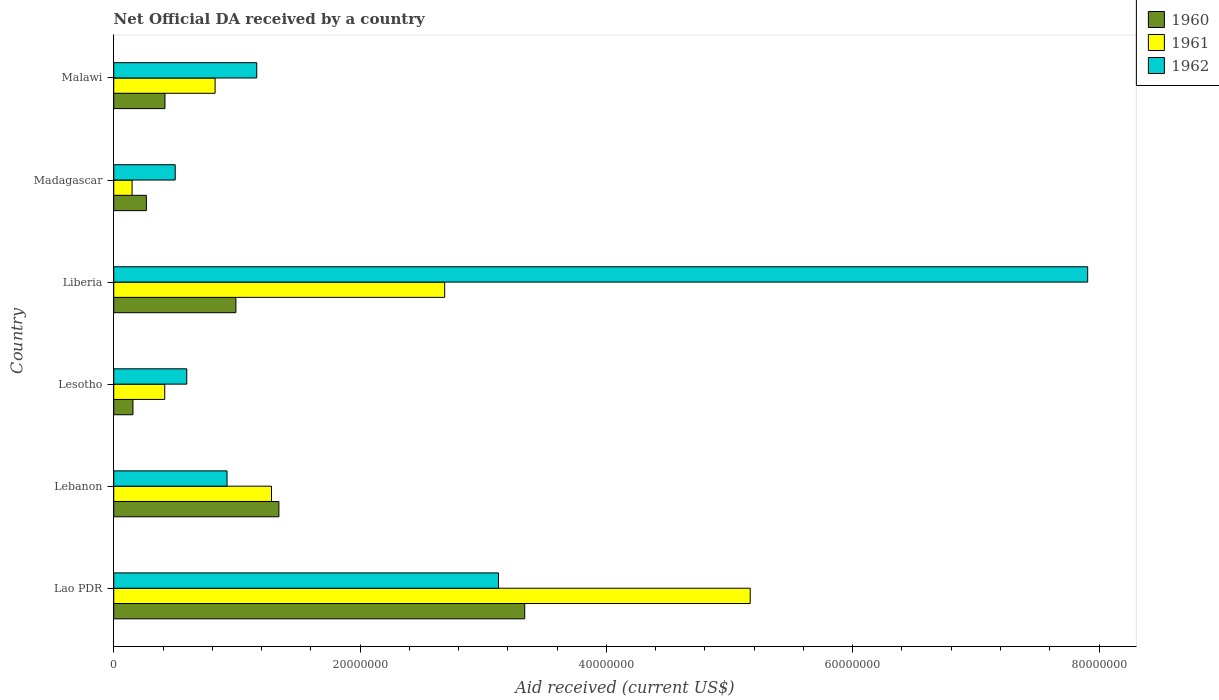How many different coloured bars are there?
Keep it short and to the point. 3. Are the number of bars on each tick of the Y-axis equal?
Your response must be concise. Yes. How many bars are there on the 1st tick from the top?
Ensure brevity in your answer.  3. How many bars are there on the 5th tick from the bottom?
Offer a very short reply. 3. What is the label of the 2nd group of bars from the top?
Make the answer very short. Madagascar. What is the net official development assistance aid received in 1962 in Liberia?
Your response must be concise. 7.91e+07. Across all countries, what is the maximum net official development assistance aid received in 1960?
Keep it short and to the point. 3.34e+07. Across all countries, what is the minimum net official development assistance aid received in 1960?
Give a very brief answer. 1.56e+06. In which country was the net official development assistance aid received in 1961 maximum?
Provide a succinct answer. Lao PDR. In which country was the net official development assistance aid received in 1961 minimum?
Your answer should be very brief. Madagascar. What is the total net official development assistance aid received in 1961 in the graph?
Your answer should be very brief. 1.05e+08. What is the difference between the net official development assistance aid received in 1961 in Lebanon and that in Liberia?
Your answer should be very brief. -1.41e+07. What is the difference between the net official development assistance aid received in 1961 in Liberia and the net official development assistance aid received in 1960 in Lebanon?
Your answer should be compact. 1.35e+07. What is the average net official development assistance aid received in 1961 per country?
Make the answer very short. 1.75e+07. What is the difference between the net official development assistance aid received in 1960 and net official development assistance aid received in 1962 in Lebanon?
Keep it short and to the point. 4.21e+06. In how many countries, is the net official development assistance aid received in 1962 greater than 20000000 US$?
Keep it short and to the point. 2. What is the ratio of the net official development assistance aid received in 1962 in Lesotho to that in Malawi?
Your response must be concise. 0.51. Is the difference between the net official development assistance aid received in 1960 in Lao PDR and Malawi greater than the difference between the net official development assistance aid received in 1962 in Lao PDR and Malawi?
Your answer should be compact. Yes. What is the difference between the highest and the second highest net official development assistance aid received in 1961?
Provide a succinct answer. 2.48e+07. What is the difference between the highest and the lowest net official development assistance aid received in 1961?
Make the answer very short. 5.02e+07. In how many countries, is the net official development assistance aid received in 1962 greater than the average net official development assistance aid received in 1962 taken over all countries?
Give a very brief answer. 2. What does the 2nd bar from the bottom in Lesotho represents?
Keep it short and to the point. 1961. What is the difference between two consecutive major ticks on the X-axis?
Keep it short and to the point. 2.00e+07. Are the values on the major ticks of X-axis written in scientific E-notation?
Ensure brevity in your answer.  No. Does the graph contain any zero values?
Your answer should be compact. No. Where does the legend appear in the graph?
Provide a short and direct response. Top right. What is the title of the graph?
Your response must be concise. Net Official DA received by a country. Does "1972" appear as one of the legend labels in the graph?
Give a very brief answer. No. What is the label or title of the X-axis?
Your response must be concise. Aid received (current US$). What is the Aid received (current US$) of 1960 in Lao PDR?
Make the answer very short. 3.34e+07. What is the Aid received (current US$) in 1961 in Lao PDR?
Offer a very short reply. 5.17e+07. What is the Aid received (current US$) in 1962 in Lao PDR?
Offer a terse response. 3.12e+07. What is the Aid received (current US$) of 1960 in Lebanon?
Your response must be concise. 1.34e+07. What is the Aid received (current US$) in 1961 in Lebanon?
Offer a terse response. 1.28e+07. What is the Aid received (current US$) in 1962 in Lebanon?
Offer a very short reply. 9.20e+06. What is the Aid received (current US$) of 1960 in Lesotho?
Offer a terse response. 1.56e+06. What is the Aid received (current US$) in 1961 in Lesotho?
Provide a short and direct response. 4.14e+06. What is the Aid received (current US$) of 1962 in Lesotho?
Ensure brevity in your answer.  5.93e+06. What is the Aid received (current US$) in 1960 in Liberia?
Ensure brevity in your answer.  9.92e+06. What is the Aid received (current US$) of 1961 in Liberia?
Give a very brief answer. 2.69e+07. What is the Aid received (current US$) in 1962 in Liberia?
Your response must be concise. 7.91e+07. What is the Aid received (current US$) of 1960 in Madagascar?
Offer a very short reply. 2.65e+06. What is the Aid received (current US$) of 1961 in Madagascar?
Your answer should be very brief. 1.49e+06. What is the Aid received (current US$) in 1962 in Madagascar?
Give a very brief answer. 4.99e+06. What is the Aid received (current US$) in 1960 in Malawi?
Provide a succinct answer. 4.16e+06. What is the Aid received (current US$) of 1961 in Malawi?
Provide a succinct answer. 8.23e+06. What is the Aid received (current US$) in 1962 in Malawi?
Offer a very short reply. 1.16e+07. Across all countries, what is the maximum Aid received (current US$) of 1960?
Give a very brief answer. 3.34e+07. Across all countries, what is the maximum Aid received (current US$) in 1961?
Make the answer very short. 5.17e+07. Across all countries, what is the maximum Aid received (current US$) of 1962?
Make the answer very short. 7.91e+07. Across all countries, what is the minimum Aid received (current US$) in 1960?
Give a very brief answer. 1.56e+06. Across all countries, what is the minimum Aid received (current US$) in 1961?
Provide a succinct answer. 1.49e+06. Across all countries, what is the minimum Aid received (current US$) of 1962?
Offer a very short reply. 4.99e+06. What is the total Aid received (current US$) of 1960 in the graph?
Your response must be concise. 6.51e+07. What is the total Aid received (current US$) in 1961 in the graph?
Your answer should be compact. 1.05e+08. What is the total Aid received (current US$) in 1962 in the graph?
Keep it short and to the point. 1.42e+08. What is the difference between the Aid received (current US$) of 1960 in Lao PDR and that in Lebanon?
Offer a terse response. 2.00e+07. What is the difference between the Aid received (current US$) in 1961 in Lao PDR and that in Lebanon?
Make the answer very short. 3.89e+07. What is the difference between the Aid received (current US$) in 1962 in Lao PDR and that in Lebanon?
Provide a succinct answer. 2.20e+07. What is the difference between the Aid received (current US$) in 1960 in Lao PDR and that in Lesotho?
Provide a short and direct response. 3.18e+07. What is the difference between the Aid received (current US$) of 1961 in Lao PDR and that in Lesotho?
Keep it short and to the point. 4.75e+07. What is the difference between the Aid received (current US$) in 1962 in Lao PDR and that in Lesotho?
Offer a terse response. 2.53e+07. What is the difference between the Aid received (current US$) of 1960 in Lao PDR and that in Liberia?
Your response must be concise. 2.34e+07. What is the difference between the Aid received (current US$) in 1961 in Lao PDR and that in Liberia?
Your answer should be very brief. 2.48e+07. What is the difference between the Aid received (current US$) in 1962 in Lao PDR and that in Liberia?
Make the answer very short. -4.78e+07. What is the difference between the Aid received (current US$) of 1960 in Lao PDR and that in Madagascar?
Provide a succinct answer. 3.07e+07. What is the difference between the Aid received (current US$) in 1961 in Lao PDR and that in Madagascar?
Keep it short and to the point. 5.02e+07. What is the difference between the Aid received (current US$) of 1962 in Lao PDR and that in Madagascar?
Keep it short and to the point. 2.62e+07. What is the difference between the Aid received (current US$) in 1960 in Lao PDR and that in Malawi?
Ensure brevity in your answer.  2.92e+07. What is the difference between the Aid received (current US$) of 1961 in Lao PDR and that in Malawi?
Give a very brief answer. 4.34e+07. What is the difference between the Aid received (current US$) in 1962 in Lao PDR and that in Malawi?
Provide a short and direct response. 1.96e+07. What is the difference between the Aid received (current US$) in 1960 in Lebanon and that in Lesotho?
Provide a short and direct response. 1.18e+07. What is the difference between the Aid received (current US$) of 1961 in Lebanon and that in Lesotho?
Provide a succinct answer. 8.67e+06. What is the difference between the Aid received (current US$) in 1962 in Lebanon and that in Lesotho?
Offer a terse response. 3.27e+06. What is the difference between the Aid received (current US$) in 1960 in Lebanon and that in Liberia?
Your response must be concise. 3.49e+06. What is the difference between the Aid received (current US$) of 1961 in Lebanon and that in Liberia?
Offer a terse response. -1.41e+07. What is the difference between the Aid received (current US$) of 1962 in Lebanon and that in Liberia?
Your answer should be compact. -6.99e+07. What is the difference between the Aid received (current US$) in 1960 in Lebanon and that in Madagascar?
Ensure brevity in your answer.  1.08e+07. What is the difference between the Aid received (current US$) of 1961 in Lebanon and that in Madagascar?
Give a very brief answer. 1.13e+07. What is the difference between the Aid received (current US$) in 1962 in Lebanon and that in Madagascar?
Your answer should be compact. 4.21e+06. What is the difference between the Aid received (current US$) in 1960 in Lebanon and that in Malawi?
Offer a very short reply. 9.25e+06. What is the difference between the Aid received (current US$) of 1961 in Lebanon and that in Malawi?
Make the answer very short. 4.58e+06. What is the difference between the Aid received (current US$) in 1962 in Lebanon and that in Malawi?
Offer a terse response. -2.41e+06. What is the difference between the Aid received (current US$) in 1960 in Lesotho and that in Liberia?
Make the answer very short. -8.36e+06. What is the difference between the Aid received (current US$) of 1961 in Lesotho and that in Liberia?
Your answer should be compact. -2.27e+07. What is the difference between the Aid received (current US$) of 1962 in Lesotho and that in Liberia?
Give a very brief answer. -7.32e+07. What is the difference between the Aid received (current US$) of 1960 in Lesotho and that in Madagascar?
Your answer should be compact. -1.09e+06. What is the difference between the Aid received (current US$) in 1961 in Lesotho and that in Madagascar?
Keep it short and to the point. 2.65e+06. What is the difference between the Aid received (current US$) of 1962 in Lesotho and that in Madagascar?
Provide a short and direct response. 9.40e+05. What is the difference between the Aid received (current US$) of 1960 in Lesotho and that in Malawi?
Your response must be concise. -2.60e+06. What is the difference between the Aid received (current US$) of 1961 in Lesotho and that in Malawi?
Ensure brevity in your answer.  -4.09e+06. What is the difference between the Aid received (current US$) of 1962 in Lesotho and that in Malawi?
Give a very brief answer. -5.68e+06. What is the difference between the Aid received (current US$) in 1960 in Liberia and that in Madagascar?
Your answer should be compact. 7.27e+06. What is the difference between the Aid received (current US$) of 1961 in Liberia and that in Madagascar?
Provide a succinct answer. 2.54e+07. What is the difference between the Aid received (current US$) in 1962 in Liberia and that in Madagascar?
Your answer should be very brief. 7.41e+07. What is the difference between the Aid received (current US$) in 1960 in Liberia and that in Malawi?
Your response must be concise. 5.76e+06. What is the difference between the Aid received (current US$) of 1961 in Liberia and that in Malawi?
Ensure brevity in your answer.  1.86e+07. What is the difference between the Aid received (current US$) in 1962 in Liberia and that in Malawi?
Offer a terse response. 6.75e+07. What is the difference between the Aid received (current US$) of 1960 in Madagascar and that in Malawi?
Provide a succinct answer. -1.51e+06. What is the difference between the Aid received (current US$) of 1961 in Madagascar and that in Malawi?
Ensure brevity in your answer.  -6.74e+06. What is the difference between the Aid received (current US$) in 1962 in Madagascar and that in Malawi?
Provide a short and direct response. -6.62e+06. What is the difference between the Aid received (current US$) in 1960 in Lao PDR and the Aid received (current US$) in 1961 in Lebanon?
Your answer should be compact. 2.06e+07. What is the difference between the Aid received (current US$) of 1960 in Lao PDR and the Aid received (current US$) of 1962 in Lebanon?
Your answer should be very brief. 2.42e+07. What is the difference between the Aid received (current US$) in 1961 in Lao PDR and the Aid received (current US$) in 1962 in Lebanon?
Your answer should be compact. 4.25e+07. What is the difference between the Aid received (current US$) of 1960 in Lao PDR and the Aid received (current US$) of 1961 in Lesotho?
Provide a short and direct response. 2.92e+07. What is the difference between the Aid received (current US$) of 1960 in Lao PDR and the Aid received (current US$) of 1962 in Lesotho?
Offer a terse response. 2.74e+07. What is the difference between the Aid received (current US$) in 1961 in Lao PDR and the Aid received (current US$) in 1962 in Lesotho?
Provide a short and direct response. 4.58e+07. What is the difference between the Aid received (current US$) of 1960 in Lao PDR and the Aid received (current US$) of 1961 in Liberia?
Your answer should be compact. 6.50e+06. What is the difference between the Aid received (current US$) of 1960 in Lao PDR and the Aid received (current US$) of 1962 in Liberia?
Offer a very short reply. -4.57e+07. What is the difference between the Aid received (current US$) of 1961 in Lao PDR and the Aid received (current US$) of 1962 in Liberia?
Offer a terse response. -2.74e+07. What is the difference between the Aid received (current US$) in 1960 in Lao PDR and the Aid received (current US$) in 1961 in Madagascar?
Keep it short and to the point. 3.19e+07. What is the difference between the Aid received (current US$) of 1960 in Lao PDR and the Aid received (current US$) of 1962 in Madagascar?
Provide a short and direct response. 2.84e+07. What is the difference between the Aid received (current US$) of 1961 in Lao PDR and the Aid received (current US$) of 1962 in Madagascar?
Offer a very short reply. 4.67e+07. What is the difference between the Aid received (current US$) in 1960 in Lao PDR and the Aid received (current US$) in 1961 in Malawi?
Provide a succinct answer. 2.51e+07. What is the difference between the Aid received (current US$) of 1960 in Lao PDR and the Aid received (current US$) of 1962 in Malawi?
Ensure brevity in your answer.  2.18e+07. What is the difference between the Aid received (current US$) of 1961 in Lao PDR and the Aid received (current US$) of 1962 in Malawi?
Your answer should be very brief. 4.01e+07. What is the difference between the Aid received (current US$) of 1960 in Lebanon and the Aid received (current US$) of 1961 in Lesotho?
Your answer should be compact. 9.27e+06. What is the difference between the Aid received (current US$) of 1960 in Lebanon and the Aid received (current US$) of 1962 in Lesotho?
Offer a terse response. 7.48e+06. What is the difference between the Aid received (current US$) of 1961 in Lebanon and the Aid received (current US$) of 1962 in Lesotho?
Your response must be concise. 6.88e+06. What is the difference between the Aid received (current US$) of 1960 in Lebanon and the Aid received (current US$) of 1961 in Liberia?
Provide a succinct answer. -1.35e+07. What is the difference between the Aid received (current US$) in 1960 in Lebanon and the Aid received (current US$) in 1962 in Liberia?
Offer a very short reply. -6.57e+07. What is the difference between the Aid received (current US$) of 1961 in Lebanon and the Aid received (current US$) of 1962 in Liberia?
Offer a very short reply. -6.63e+07. What is the difference between the Aid received (current US$) in 1960 in Lebanon and the Aid received (current US$) in 1961 in Madagascar?
Give a very brief answer. 1.19e+07. What is the difference between the Aid received (current US$) in 1960 in Lebanon and the Aid received (current US$) in 1962 in Madagascar?
Ensure brevity in your answer.  8.42e+06. What is the difference between the Aid received (current US$) in 1961 in Lebanon and the Aid received (current US$) in 1962 in Madagascar?
Your answer should be compact. 7.82e+06. What is the difference between the Aid received (current US$) in 1960 in Lebanon and the Aid received (current US$) in 1961 in Malawi?
Your response must be concise. 5.18e+06. What is the difference between the Aid received (current US$) in 1960 in Lebanon and the Aid received (current US$) in 1962 in Malawi?
Your answer should be very brief. 1.80e+06. What is the difference between the Aid received (current US$) of 1961 in Lebanon and the Aid received (current US$) of 1962 in Malawi?
Make the answer very short. 1.20e+06. What is the difference between the Aid received (current US$) in 1960 in Lesotho and the Aid received (current US$) in 1961 in Liberia?
Offer a very short reply. -2.53e+07. What is the difference between the Aid received (current US$) of 1960 in Lesotho and the Aid received (current US$) of 1962 in Liberia?
Ensure brevity in your answer.  -7.75e+07. What is the difference between the Aid received (current US$) of 1961 in Lesotho and the Aid received (current US$) of 1962 in Liberia?
Make the answer very short. -7.49e+07. What is the difference between the Aid received (current US$) in 1960 in Lesotho and the Aid received (current US$) in 1961 in Madagascar?
Your answer should be very brief. 7.00e+04. What is the difference between the Aid received (current US$) of 1960 in Lesotho and the Aid received (current US$) of 1962 in Madagascar?
Give a very brief answer. -3.43e+06. What is the difference between the Aid received (current US$) of 1961 in Lesotho and the Aid received (current US$) of 1962 in Madagascar?
Ensure brevity in your answer.  -8.50e+05. What is the difference between the Aid received (current US$) in 1960 in Lesotho and the Aid received (current US$) in 1961 in Malawi?
Your answer should be very brief. -6.67e+06. What is the difference between the Aid received (current US$) in 1960 in Lesotho and the Aid received (current US$) in 1962 in Malawi?
Give a very brief answer. -1.00e+07. What is the difference between the Aid received (current US$) of 1961 in Lesotho and the Aid received (current US$) of 1962 in Malawi?
Make the answer very short. -7.47e+06. What is the difference between the Aid received (current US$) of 1960 in Liberia and the Aid received (current US$) of 1961 in Madagascar?
Offer a very short reply. 8.43e+06. What is the difference between the Aid received (current US$) in 1960 in Liberia and the Aid received (current US$) in 1962 in Madagascar?
Offer a very short reply. 4.93e+06. What is the difference between the Aid received (current US$) in 1961 in Liberia and the Aid received (current US$) in 1962 in Madagascar?
Provide a short and direct response. 2.19e+07. What is the difference between the Aid received (current US$) of 1960 in Liberia and the Aid received (current US$) of 1961 in Malawi?
Your answer should be compact. 1.69e+06. What is the difference between the Aid received (current US$) of 1960 in Liberia and the Aid received (current US$) of 1962 in Malawi?
Provide a succinct answer. -1.69e+06. What is the difference between the Aid received (current US$) in 1961 in Liberia and the Aid received (current US$) in 1962 in Malawi?
Your answer should be compact. 1.53e+07. What is the difference between the Aid received (current US$) in 1960 in Madagascar and the Aid received (current US$) in 1961 in Malawi?
Ensure brevity in your answer.  -5.58e+06. What is the difference between the Aid received (current US$) in 1960 in Madagascar and the Aid received (current US$) in 1962 in Malawi?
Provide a short and direct response. -8.96e+06. What is the difference between the Aid received (current US$) in 1961 in Madagascar and the Aid received (current US$) in 1962 in Malawi?
Make the answer very short. -1.01e+07. What is the average Aid received (current US$) of 1960 per country?
Provide a short and direct response. 1.08e+07. What is the average Aid received (current US$) in 1961 per country?
Offer a terse response. 1.75e+07. What is the average Aid received (current US$) of 1962 per country?
Provide a short and direct response. 2.37e+07. What is the difference between the Aid received (current US$) in 1960 and Aid received (current US$) in 1961 in Lao PDR?
Your response must be concise. -1.83e+07. What is the difference between the Aid received (current US$) in 1960 and Aid received (current US$) in 1962 in Lao PDR?
Provide a succinct answer. 2.13e+06. What is the difference between the Aid received (current US$) in 1961 and Aid received (current US$) in 1962 in Lao PDR?
Your response must be concise. 2.04e+07. What is the difference between the Aid received (current US$) in 1960 and Aid received (current US$) in 1962 in Lebanon?
Provide a succinct answer. 4.21e+06. What is the difference between the Aid received (current US$) of 1961 and Aid received (current US$) of 1962 in Lebanon?
Your answer should be very brief. 3.61e+06. What is the difference between the Aid received (current US$) in 1960 and Aid received (current US$) in 1961 in Lesotho?
Make the answer very short. -2.58e+06. What is the difference between the Aid received (current US$) of 1960 and Aid received (current US$) of 1962 in Lesotho?
Make the answer very short. -4.37e+06. What is the difference between the Aid received (current US$) in 1961 and Aid received (current US$) in 1962 in Lesotho?
Your answer should be very brief. -1.79e+06. What is the difference between the Aid received (current US$) in 1960 and Aid received (current US$) in 1961 in Liberia?
Offer a very short reply. -1.70e+07. What is the difference between the Aid received (current US$) in 1960 and Aid received (current US$) in 1962 in Liberia?
Offer a very short reply. -6.92e+07. What is the difference between the Aid received (current US$) in 1961 and Aid received (current US$) in 1962 in Liberia?
Provide a succinct answer. -5.22e+07. What is the difference between the Aid received (current US$) in 1960 and Aid received (current US$) in 1961 in Madagascar?
Give a very brief answer. 1.16e+06. What is the difference between the Aid received (current US$) of 1960 and Aid received (current US$) of 1962 in Madagascar?
Ensure brevity in your answer.  -2.34e+06. What is the difference between the Aid received (current US$) in 1961 and Aid received (current US$) in 1962 in Madagascar?
Offer a terse response. -3.50e+06. What is the difference between the Aid received (current US$) of 1960 and Aid received (current US$) of 1961 in Malawi?
Keep it short and to the point. -4.07e+06. What is the difference between the Aid received (current US$) in 1960 and Aid received (current US$) in 1962 in Malawi?
Your answer should be very brief. -7.45e+06. What is the difference between the Aid received (current US$) of 1961 and Aid received (current US$) of 1962 in Malawi?
Your answer should be very brief. -3.38e+06. What is the ratio of the Aid received (current US$) of 1960 in Lao PDR to that in Lebanon?
Your answer should be compact. 2.49. What is the ratio of the Aid received (current US$) in 1961 in Lao PDR to that in Lebanon?
Provide a short and direct response. 4.03. What is the ratio of the Aid received (current US$) in 1962 in Lao PDR to that in Lebanon?
Keep it short and to the point. 3.4. What is the ratio of the Aid received (current US$) of 1960 in Lao PDR to that in Lesotho?
Provide a succinct answer. 21.39. What is the ratio of the Aid received (current US$) in 1961 in Lao PDR to that in Lesotho?
Provide a short and direct response. 12.48. What is the ratio of the Aid received (current US$) of 1962 in Lao PDR to that in Lesotho?
Give a very brief answer. 5.27. What is the ratio of the Aid received (current US$) of 1960 in Lao PDR to that in Liberia?
Offer a very short reply. 3.36. What is the ratio of the Aid received (current US$) of 1961 in Lao PDR to that in Liberia?
Offer a terse response. 1.92. What is the ratio of the Aid received (current US$) of 1962 in Lao PDR to that in Liberia?
Provide a short and direct response. 0.4. What is the ratio of the Aid received (current US$) in 1960 in Lao PDR to that in Madagascar?
Make the answer very short. 12.59. What is the ratio of the Aid received (current US$) in 1961 in Lao PDR to that in Madagascar?
Your answer should be compact. 34.68. What is the ratio of the Aid received (current US$) in 1962 in Lao PDR to that in Madagascar?
Your answer should be very brief. 6.26. What is the ratio of the Aid received (current US$) in 1960 in Lao PDR to that in Malawi?
Offer a terse response. 8.02. What is the ratio of the Aid received (current US$) in 1961 in Lao PDR to that in Malawi?
Your answer should be very brief. 6.28. What is the ratio of the Aid received (current US$) in 1962 in Lao PDR to that in Malawi?
Provide a short and direct response. 2.69. What is the ratio of the Aid received (current US$) in 1960 in Lebanon to that in Lesotho?
Offer a very short reply. 8.6. What is the ratio of the Aid received (current US$) in 1961 in Lebanon to that in Lesotho?
Provide a short and direct response. 3.09. What is the ratio of the Aid received (current US$) of 1962 in Lebanon to that in Lesotho?
Make the answer very short. 1.55. What is the ratio of the Aid received (current US$) in 1960 in Lebanon to that in Liberia?
Provide a succinct answer. 1.35. What is the ratio of the Aid received (current US$) of 1961 in Lebanon to that in Liberia?
Your answer should be very brief. 0.48. What is the ratio of the Aid received (current US$) in 1962 in Lebanon to that in Liberia?
Your answer should be very brief. 0.12. What is the ratio of the Aid received (current US$) in 1960 in Lebanon to that in Madagascar?
Provide a short and direct response. 5.06. What is the ratio of the Aid received (current US$) in 1961 in Lebanon to that in Madagascar?
Provide a succinct answer. 8.6. What is the ratio of the Aid received (current US$) of 1962 in Lebanon to that in Madagascar?
Make the answer very short. 1.84. What is the ratio of the Aid received (current US$) of 1960 in Lebanon to that in Malawi?
Your response must be concise. 3.22. What is the ratio of the Aid received (current US$) in 1961 in Lebanon to that in Malawi?
Ensure brevity in your answer.  1.56. What is the ratio of the Aid received (current US$) in 1962 in Lebanon to that in Malawi?
Give a very brief answer. 0.79. What is the ratio of the Aid received (current US$) in 1960 in Lesotho to that in Liberia?
Your answer should be compact. 0.16. What is the ratio of the Aid received (current US$) in 1961 in Lesotho to that in Liberia?
Your answer should be compact. 0.15. What is the ratio of the Aid received (current US$) in 1962 in Lesotho to that in Liberia?
Offer a terse response. 0.07. What is the ratio of the Aid received (current US$) in 1960 in Lesotho to that in Madagascar?
Make the answer very short. 0.59. What is the ratio of the Aid received (current US$) in 1961 in Lesotho to that in Madagascar?
Ensure brevity in your answer.  2.78. What is the ratio of the Aid received (current US$) of 1962 in Lesotho to that in Madagascar?
Ensure brevity in your answer.  1.19. What is the ratio of the Aid received (current US$) of 1961 in Lesotho to that in Malawi?
Ensure brevity in your answer.  0.5. What is the ratio of the Aid received (current US$) in 1962 in Lesotho to that in Malawi?
Offer a very short reply. 0.51. What is the ratio of the Aid received (current US$) of 1960 in Liberia to that in Madagascar?
Your response must be concise. 3.74. What is the ratio of the Aid received (current US$) of 1961 in Liberia to that in Madagascar?
Provide a short and direct response. 18.03. What is the ratio of the Aid received (current US$) of 1962 in Liberia to that in Madagascar?
Keep it short and to the point. 15.85. What is the ratio of the Aid received (current US$) in 1960 in Liberia to that in Malawi?
Your answer should be compact. 2.38. What is the ratio of the Aid received (current US$) of 1961 in Liberia to that in Malawi?
Offer a terse response. 3.26. What is the ratio of the Aid received (current US$) in 1962 in Liberia to that in Malawi?
Ensure brevity in your answer.  6.81. What is the ratio of the Aid received (current US$) in 1960 in Madagascar to that in Malawi?
Give a very brief answer. 0.64. What is the ratio of the Aid received (current US$) of 1961 in Madagascar to that in Malawi?
Give a very brief answer. 0.18. What is the ratio of the Aid received (current US$) in 1962 in Madagascar to that in Malawi?
Your answer should be compact. 0.43. What is the difference between the highest and the second highest Aid received (current US$) in 1960?
Give a very brief answer. 2.00e+07. What is the difference between the highest and the second highest Aid received (current US$) in 1961?
Ensure brevity in your answer.  2.48e+07. What is the difference between the highest and the second highest Aid received (current US$) in 1962?
Offer a very short reply. 4.78e+07. What is the difference between the highest and the lowest Aid received (current US$) of 1960?
Offer a very short reply. 3.18e+07. What is the difference between the highest and the lowest Aid received (current US$) in 1961?
Offer a terse response. 5.02e+07. What is the difference between the highest and the lowest Aid received (current US$) of 1962?
Your answer should be compact. 7.41e+07. 